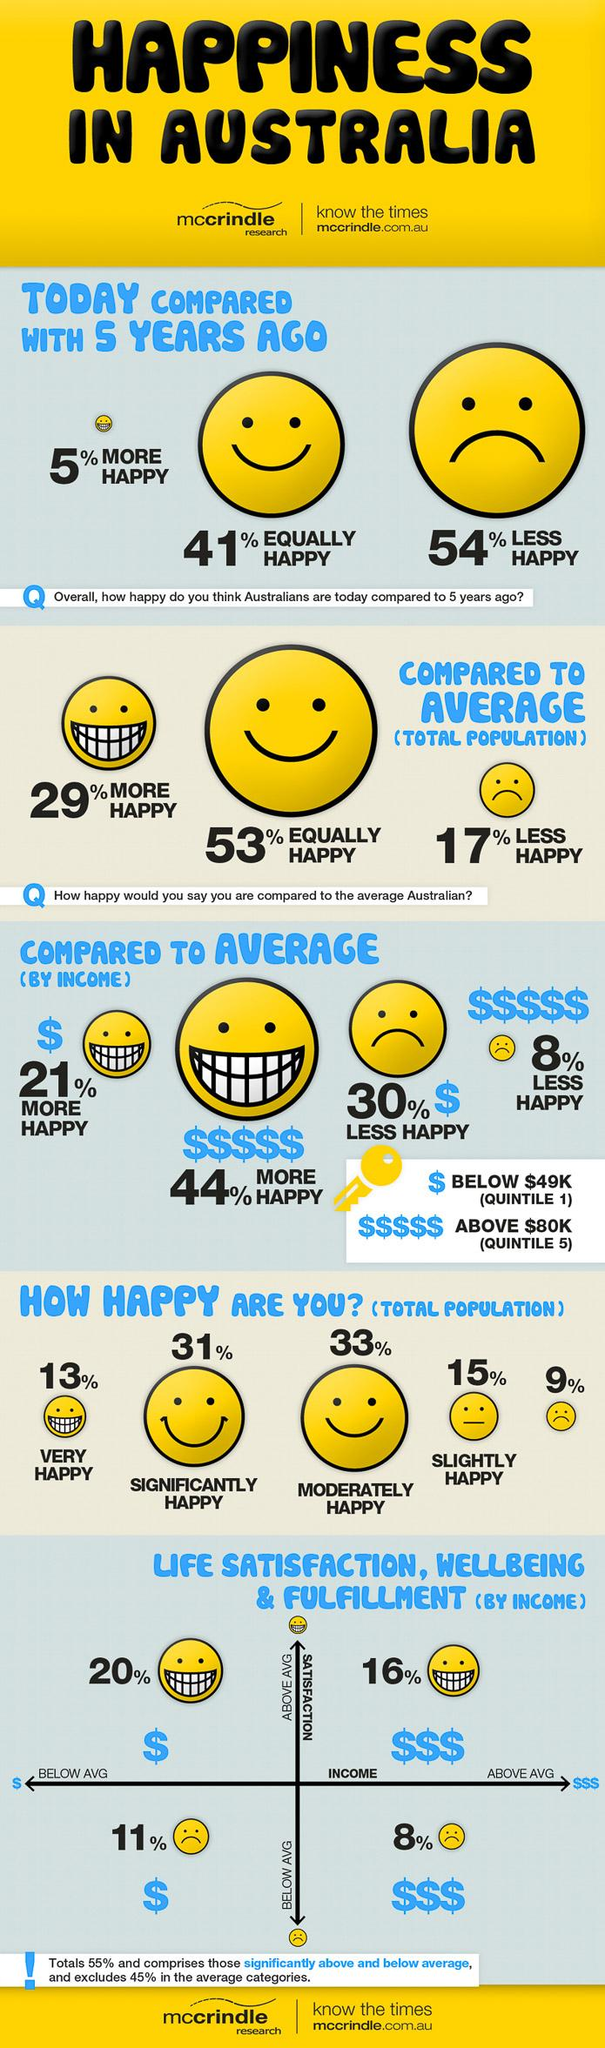Point out several critical features in this image. According to a recent survey, approximately 15% of the population self-identifies as "slightly happy," indicating a moderate level of contentment in their lives. According to a recent survey, 33% of the population is considered moderately happy. 